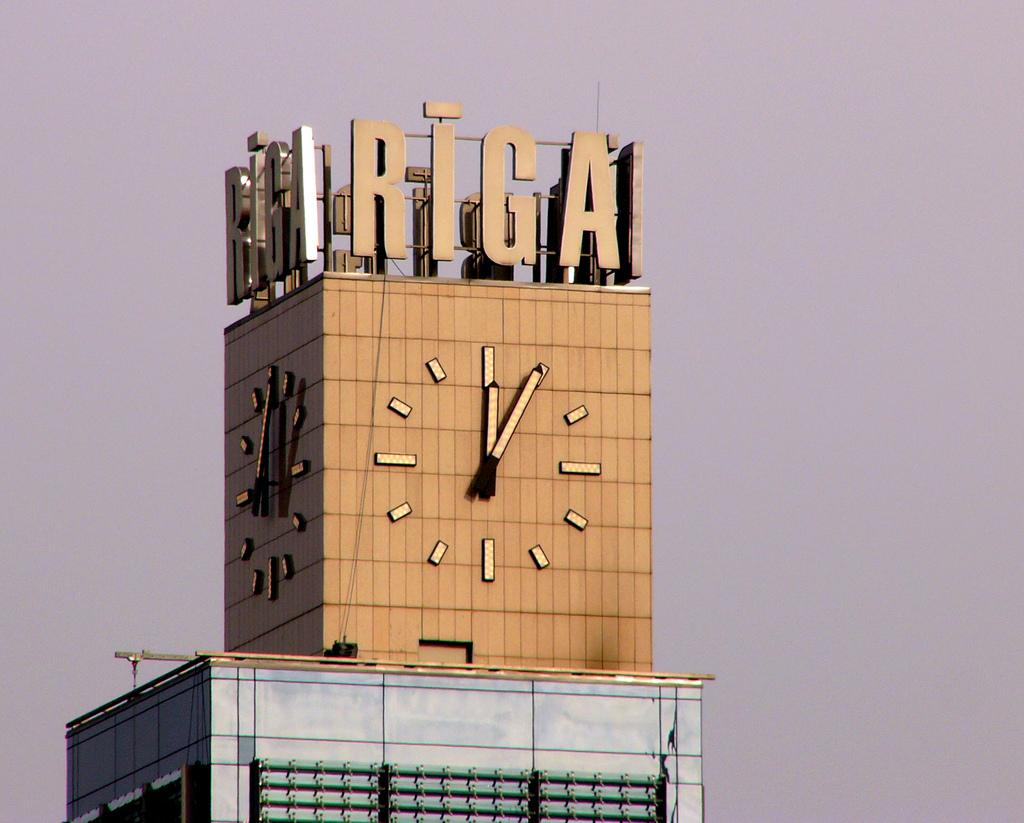What type of building is depicted in the image? There is a glass building in the image. What design can be seen on the wall at the top of the building? There is a clock design on the wall at the top of the building. What can be seen in the sky in the image? There are clouds in the sky. What type of shock can be seen coming from the oven in the image? There is no oven present in the image, so no shock can be observed. How many needles are visible in the image? There are no needles present in the image. 